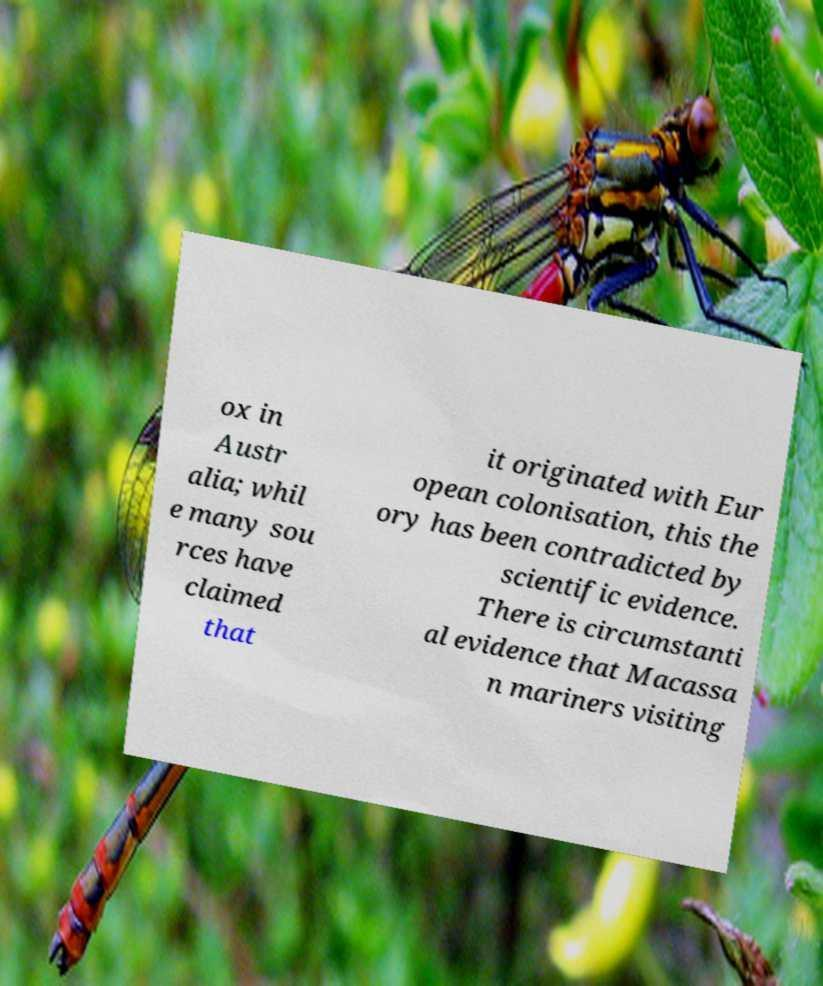Can you read and provide the text displayed in the image?This photo seems to have some interesting text. Can you extract and type it out for me? ox in Austr alia; whil e many sou rces have claimed that it originated with Eur opean colonisation, this the ory has been contradicted by scientific evidence. There is circumstanti al evidence that Macassa n mariners visiting 